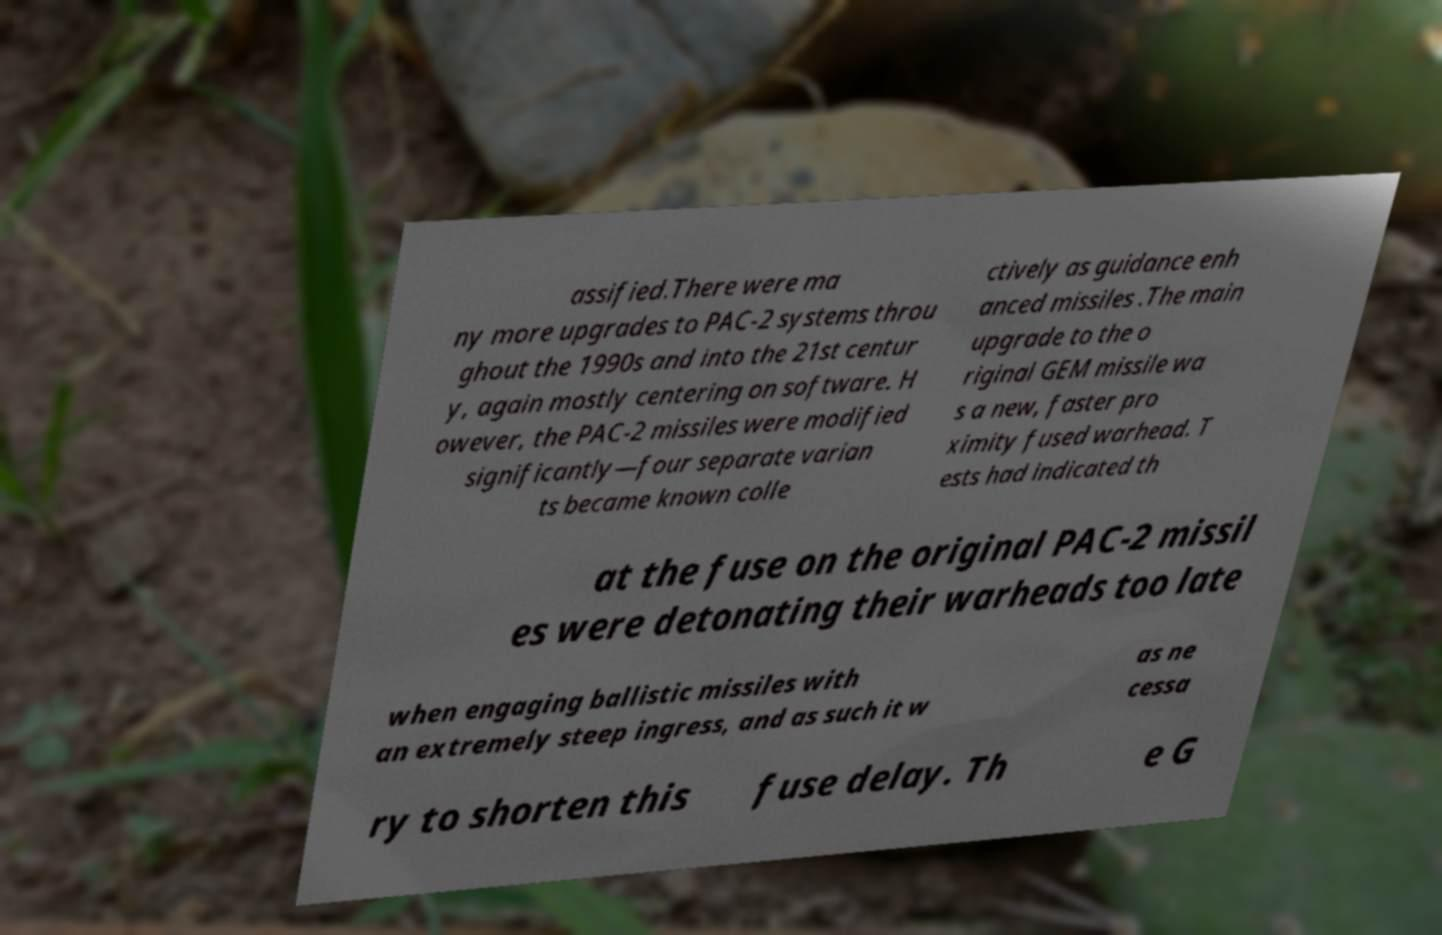Please read and relay the text visible in this image. What does it say? assified.There were ma ny more upgrades to PAC-2 systems throu ghout the 1990s and into the 21st centur y, again mostly centering on software. H owever, the PAC-2 missiles were modified significantly—four separate varian ts became known colle ctively as guidance enh anced missiles .The main upgrade to the o riginal GEM missile wa s a new, faster pro ximity fused warhead. T ests had indicated th at the fuse on the original PAC-2 missil es were detonating their warheads too late when engaging ballistic missiles with an extremely steep ingress, and as such it w as ne cessa ry to shorten this fuse delay. Th e G 